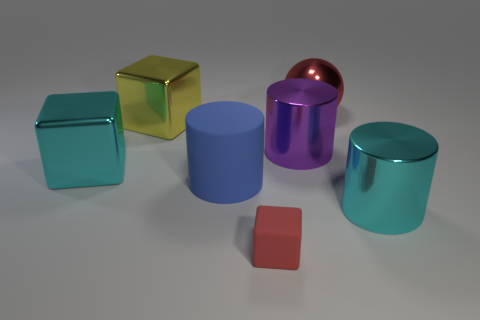Add 2 large green cubes. How many objects exist? 9 Subtract all large metal blocks. How many blocks are left? 1 Subtract all blocks. How many objects are left? 4 Subtract 1 cubes. How many cubes are left? 2 Subtract all yellow spheres. Subtract all green blocks. How many spheres are left? 1 Subtract all red spheres. How many blue cylinders are left? 1 Subtract all large red balls. Subtract all large cyan cylinders. How many objects are left? 5 Add 7 large metallic balls. How many large metallic balls are left? 8 Add 3 cyan cylinders. How many cyan cylinders exist? 4 Subtract 0 green cubes. How many objects are left? 7 